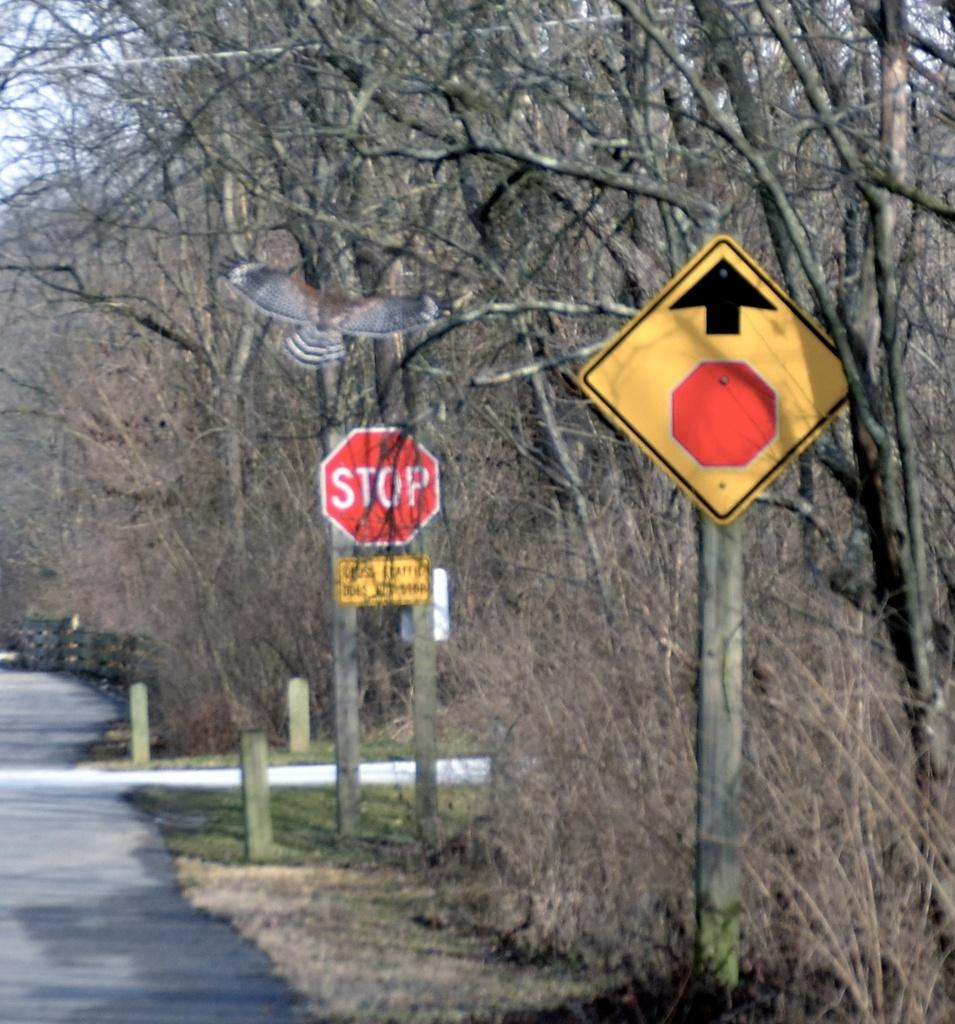What type of vegetation can be seen in the image? There are trees in the image. What man-made structure is present in the image? There is a sign board in the image. What type of barrier is visible in the image? There is a fence in the image. What type of pathway is present in the image? There is a road in the image. What vertical structures can be seen in the image? There are poles in the image. What animal can be seen in the image? A bird is flying in the image. Where is the donkey standing in the image? There is no donkey present in the image. What type of fruit is hanging from the poles in the image? There is no fruit, specifically quince, hanging from the poles in the image. 